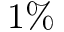Convert formula to latex. <formula><loc_0><loc_0><loc_500><loc_500>1 \%</formula> 